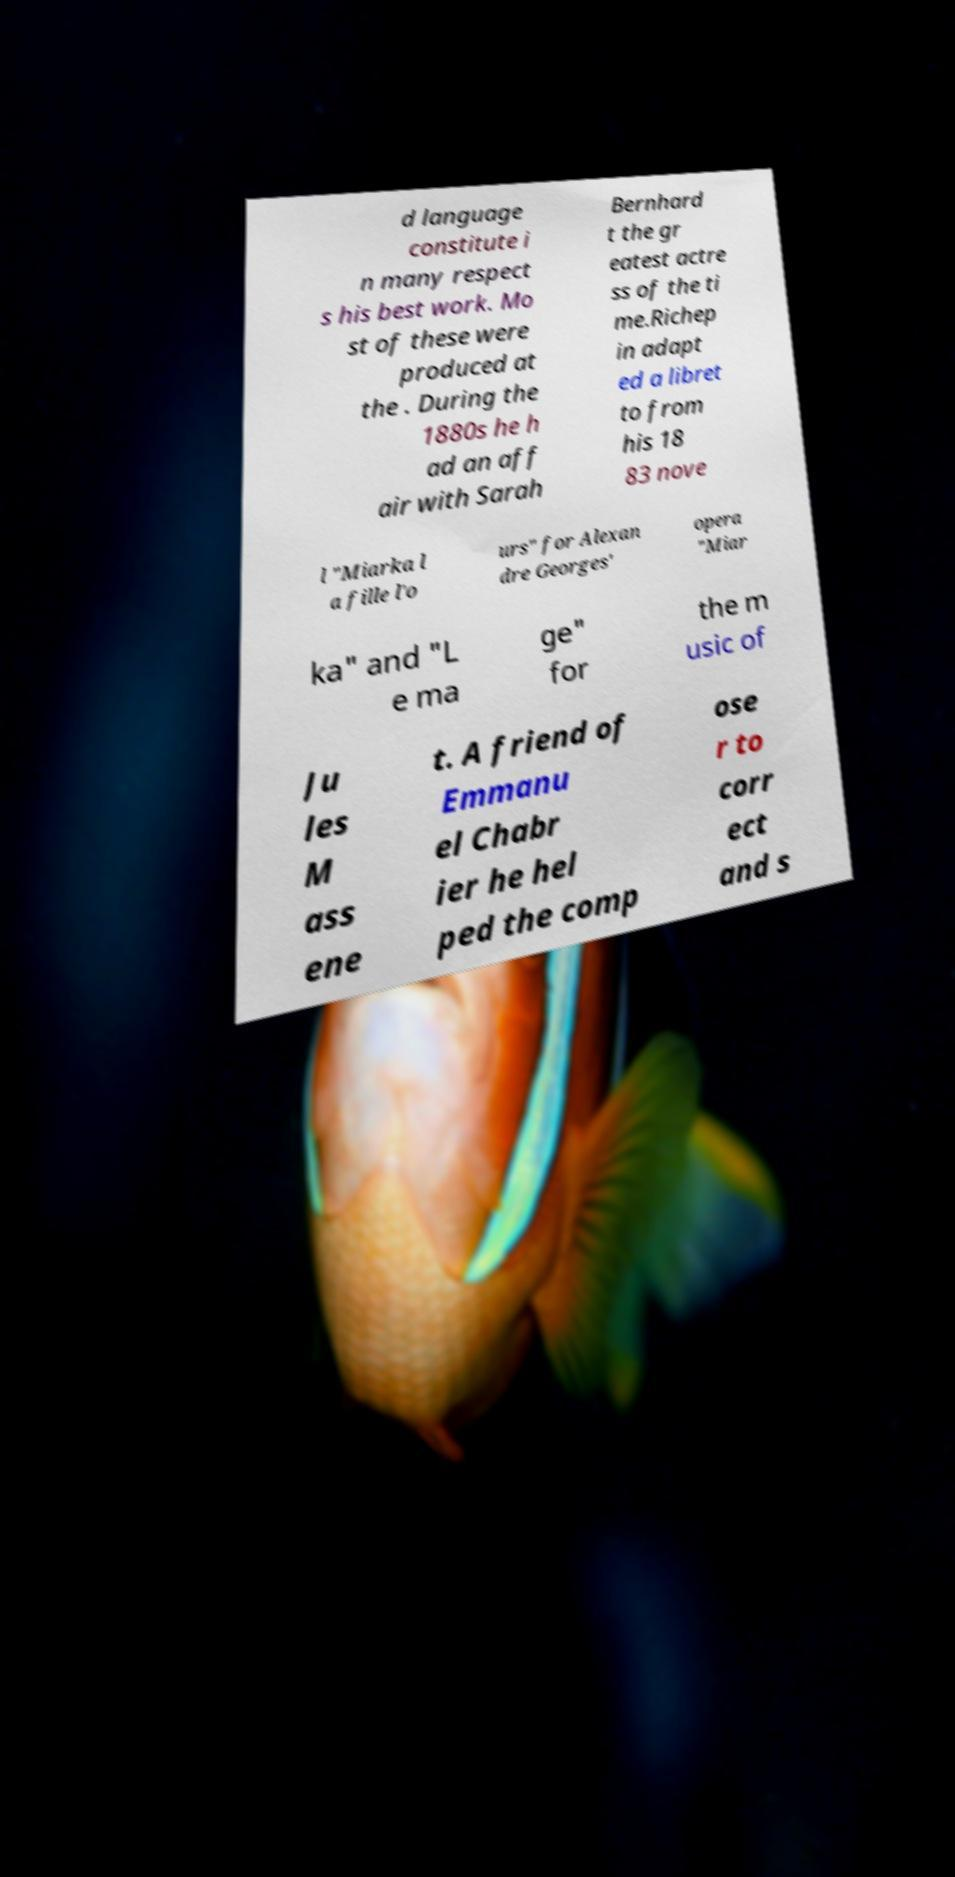Please read and relay the text visible in this image. What does it say? d language constitute i n many respect s his best work. Mo st of these were produced at the . During the 1880s he h ad an aff air with Sarah Bernhard t the gr eatest actre ss of the ti me.Richep in adapt ed a libret to from his 18 83 nove l "Miarka l a fille l'o urs" for Alexan dre Georges' opera "Miar ka" and "L e ma ge" for the m usic of Ju les M ass ene t. A friend of Emmanu el Chabr ier he hel ped the comp ose r to corr ect and s 